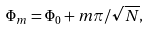<formula> <loc_0><loc_0><loc_500><loc_500>\Phi _ { m } = \Phi _ { 0 } + m \pi / \sqrt { N } ,</formula> 